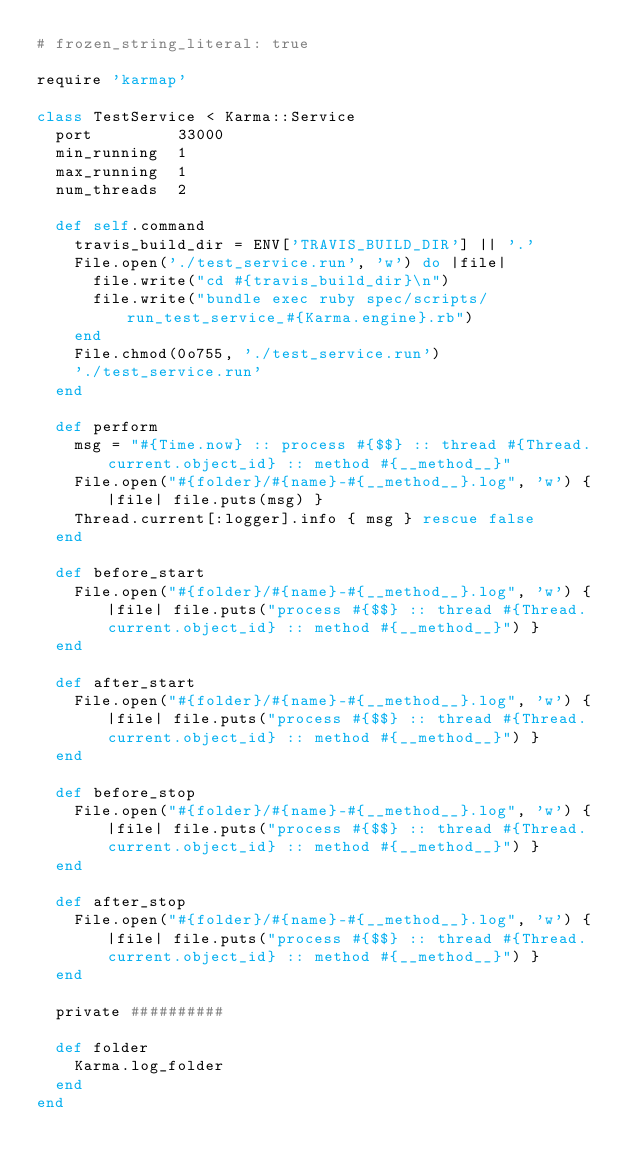Convert code to text. <code><loc_0><loc_0><loc_500><loc_500><_Ruby_># frozen_string_literal: true

require 'karmap'

class TestService < Karma::Service
  port         33000
  min_running  1
  max_running  1
  num_threads  2

  def self.command
    travis_build_dir = ENV['TRAVIS_BUILD_DIR'] || '.'
    File.open('./test_service.run', 'w') do |file|
      file.write("cd #{travis_build_dir}\n")
      file.write("bundle exec ruby spec/scripts/run_test_service_#{Karma.engine}.rb")
    end
    File.chmod(0o755, './test_service.run')
    './test_service.run'
  end

  def perform
    msg = "#{Time.now} :: process #{$$} :: thread #{Thread.current.object_id} :: method #{__method__}"
    File.open("#{folder}/#{name}-#{__method__}.log", 'w') { |file| file.puts(msg) }
    Thread.current[:logger].info { msg } rescue false
  end

  def before_start
    File.open("#{folder}/#{name}-#{__method__}.log", 'w') { |file| file.puts("process #{$$} :: thread #{Thread.current.object_id} :: method #{__method__}") }
  end

  def after_start
    File.open("#{folder}/#{name}-#{__method__}.log", 'w') { |file| file.puts("process #{$$} :: thread #{Thread.current.object_id} :: method #{__method__}") }
  end

  def before_stop
    File.open("#{folder}/#{name}-#{__method__}.log", 'w') { |file| file.puts("process #{$$} :: thread #{Thread.current.object_id} :: method #{__method__}") }
  end

  def after_stop
    File.open("#{folder}/#{name}-#{__method__}.log", 'w') { |file| file.puts("process #{$$} :: thread #{Thread.current.object_id} :: method #{__method__}") }
  end

  private ##########

  def folder
    Karma.log_folder
  end
end
</code> 